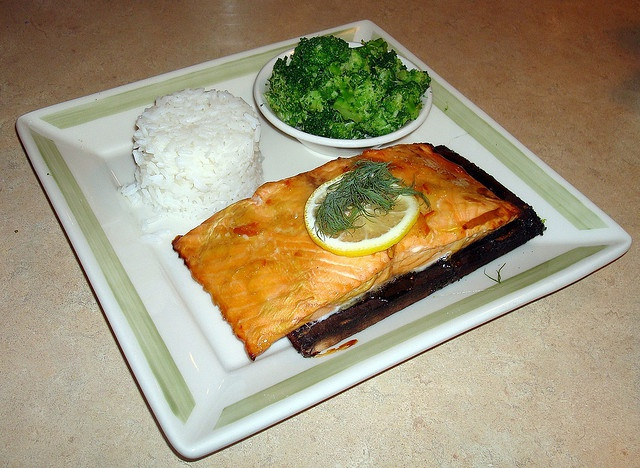Describe the objects in this image and their specific colors. I can see bowl in maroon, darkgreen, and green tones, broccoli in maroon, darkgreen, and green tones, and orange in maroon, tan, beige, khaki, and gold tones in this image. 